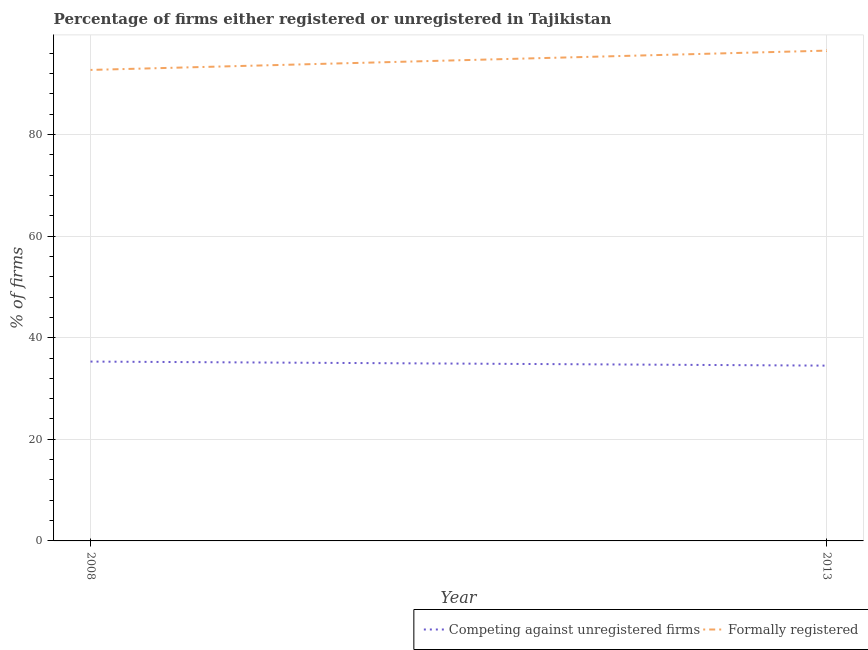How many different coloured lines are there?
Make the answer very short. 2. Is the number of lines equal to the number of legend labels?
Make the answer very short. Yes. What is the percentage of formally registered firms in 2013?
Your response must be concise. 96.5. Across all years, what is the maximum percentage of registered firms?
Offer a terse response. 35.3. Across all years, what is the minimum percentage of registered firms?
Provide a succinct answer. 34.5. In which year was the percentage of formally registered firms maximum?
Your response must be concise. 2013. In which year was the percentage of registered firms minimum?
Your answer should be compact. 2013. What is the total percentage of formally registered firms in the graph?
Your answer should be compact. 189.2. What is the difference between the percentage of registered firms in 2008 and that in 2013?
Provide a succinct answer. 0.8. What is the difference between the percentage of registered firms in 2013 and the percentage of formally registered firms in 2008?
Provide a succinct answer. -58.2. What is the average percentage of registered firms per year?
Give a very brief answer. 34.9. In the year 2008, what is the difference between the percentage of registered firms and percentage of formally registered firms?
Your answer should be very brief. -57.4. What is the ratio of the percentage of registered firms in 2008 to that in 2013?
Keep it short and to the point. 1.02. Is the percentage of registered firms in 2008 less than that in 2013?
Provide a short and direct response. No. Does the percentage of registered firms monotonically increase over the years?
Provide a short and direct response. No. What is the difference between two consecutive major ticks on the Y-axis?
Make the answer very short. 20. Does the graph contain any zero values?
Provide a succinct answer. No. Does the graph contain grids?
Ensure brevity in your answer.  Yes. How are the legend labels stacked?
Provide a succinct answer. Horizontal. What is the title of the graph?
Offer a terse response. Percentage of firms either registered or unregistered in Tajikistan. Does "constant 2005 US$" appear as one of the legend labels in the graph?
Keep it short and to the point. No. What is the label or title of the Y-axis?
Provide a succinct answer. % of firms. What is the % of firms of Competing against unregistered firms in 2008?
Your answer should be compact. 35.3. What is the % of firms of Formally registered in 2008?
Make the answer very short. 92.7. What is the % of firms in Competing against unregistered firms in 2013?
Make the answer very short. 34.5. What is the % of firms of Formally registered in 2013?
Provide a short and direct response. 96.5. Across all years, what is the maximum % of firms of Competing against unregistered firms?
Make the answer very short. 35.3. Across all years, what is the maximum % of firms in Formally registered?
Ensure brevity in your answer.  96.5. Across all years, what is the minimum % of firms of Competing against unregistered firms?
Offer a very short reply. 34.5. Across all years, what is the minimum % of firms of Formally registered?
Your answer should be compact. 92.7. What is the total % of firms in Competing against unregistered firms in the graph?
Offer a very short reply. 69.8. What is the total % of firms in Formally registered in the graph?
Your response must be concise. 189.2. What is the difference between the % of firms in Competing against unregistered firms in 2008 and the % of firms in Formally registered in 2013?
Provide a short and direct response. -61.2. What is the average % of firms of Competing against unregistered firms per year?
Keep it short and to the point. 34.9. What is the average % of firms of Formally registered per year?
Your answer should be very brief. 94.6. In the year 2008, what is the difference between the % of firms in Competing against unregistered firms and % of firms in Formally registered?
Give a very brief answer. -57.4. In the year 2013, what is the difference between the % of firms in Competing against unregistered firms and % of firms in Formally registered?
Offer a very short reply. -62. What is the ratio of the % of firms in Competing against unregistered firms in 2008 to that in 2013?
Keep it short and to the point. 1.02. What is the ratio of the % of firms of Formally registered in 2008 to that in 2013?
Your answer should be very brief. 0.96. What is the difference between the highest and the second highest % of firms of Competing against unregistered firms?
Offer a terse response. 0.8. What is the difference between the highest and the second highest % of firms in Formally registered?
Make the answer very short. 3.8. 